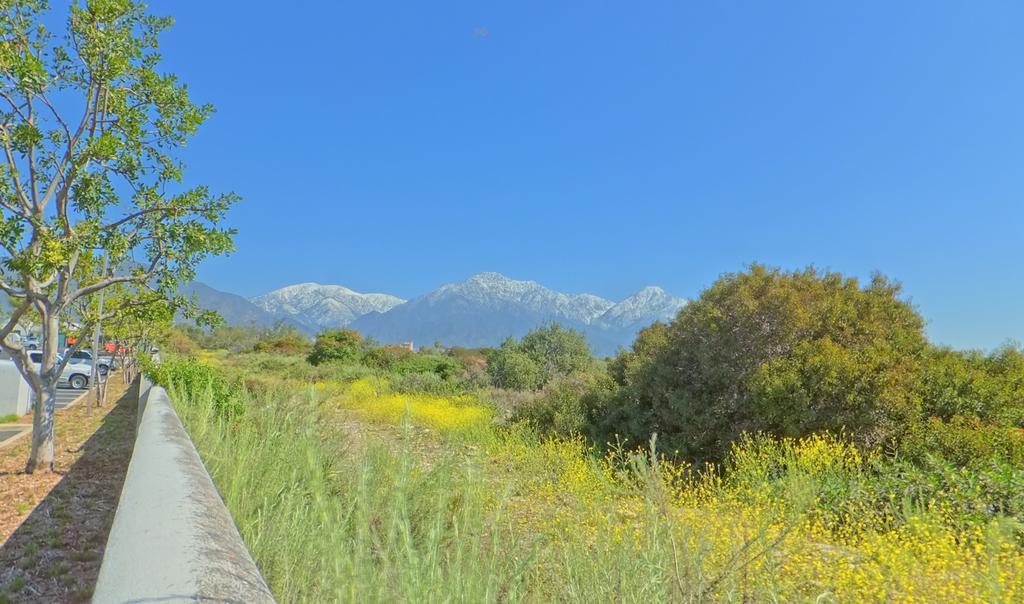Please provide a concise description of this image. In this image on the left side there are cars and trees. In the center there is a railing and on the right side there are trees, mountains and there is grass on the ground. 